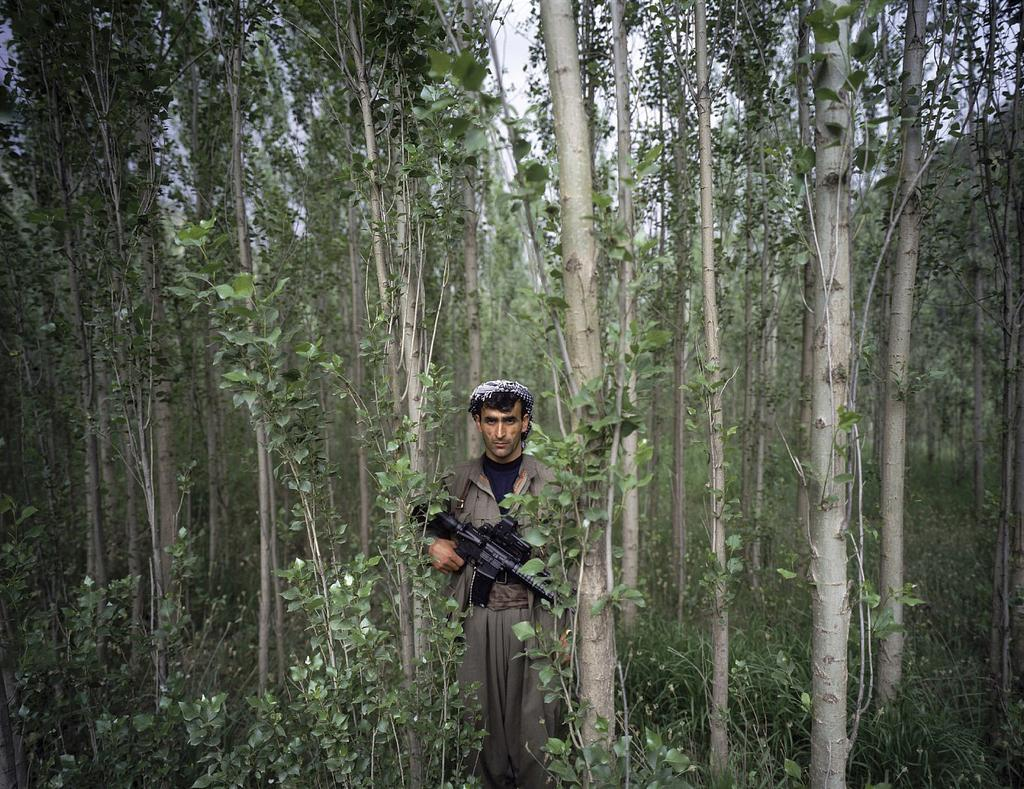What is the main subject of the picture? There is a person standing in the center of the picture. What is the person holding in the image? The person is holding a gun. What type of natural elements can be seen in the image? There are trees and plants in the image. What type of jam can be seen on the person's clothing in the image? There is no jam present on the person's clothing in the image. What type of cloud can be seen in the image? There is no cloud visible in the image. 